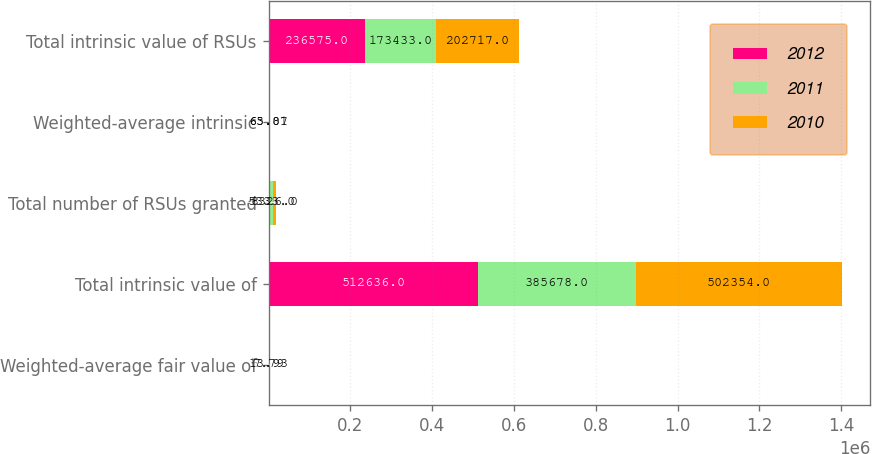Convert chart to OTSL. <chart><loc_0><loc_0><loc_500><loc_500><stacked_bar_chart><ecel><fcel>Weighted-average fair value of<fcel>Total intrinsic value of<fcel>Total number of RSUs granted<fcel>Weighted-average intrinsic<fcel>Total intrinsic value of RSUs<nl><fcel>2012<fcel>6.86<fcel>512636<fcel>4404<fcel>66.64<fcel>236575<nl><fcel>2011<fcel>7.79<fcel>385678<fcel>5333<fcel>63.87<fcel>173433<nl><fcel>2010<fcel>13.93<fcel>502354<fcel>8326<fcel>65.01<fcel>202717<nl></chart> 